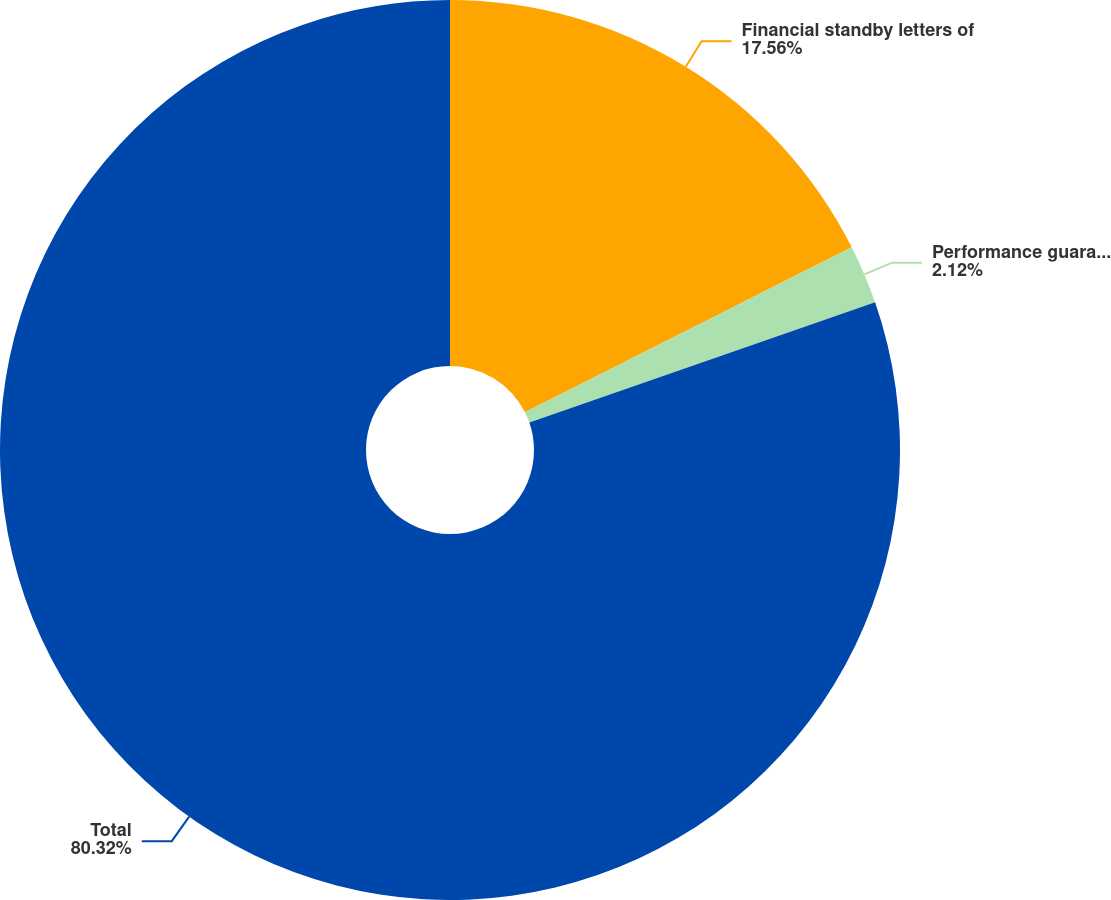Convert chart. <chart><loc_0><loc_0><loc_500><loc_500><pie_chart><fcel>Financial standby letters of<fcel>Performance guarantees<fcel>Total<nl><fcel>17.56%<fcel>2.12%<fcel>80.32%<nl></chart> 